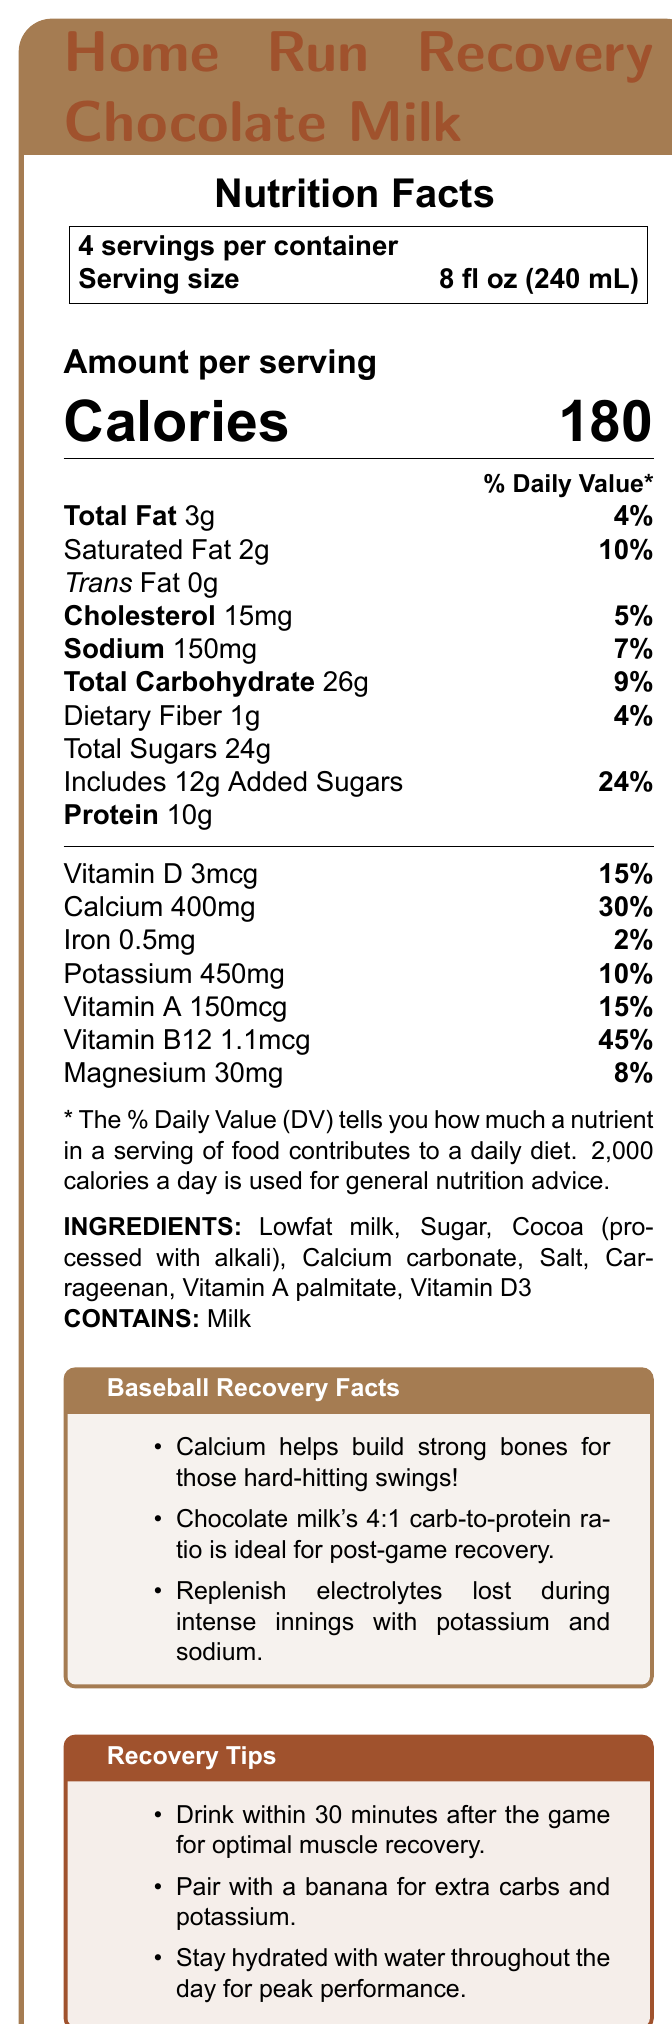What is the serving size of the "Home Run Recovery Chocolate Milk"? The serving size is explicitly mentioned in the document as "8 fl oz (240 mL)".
Answer: 8 fl oz (240 mL) How many calories are there per serving? The document states that each serving contains 180 calories.
Answer: 180 calories How many servings are there per container? The document specifies that there are 4 servings per container.
Answer: 4 What percentage of the daily value of calcium does one serving provide? The document shows that one serving provides 30% of the daily value of calcium.
Answer: 30% What is the amount of protein in one serving? The document lists the amount of protein per serving as 10g.
Answer: 10g What are the total sugars contained in one serving? A. 10g B. 20g C. 24g D. 30g The document states that the total sugars in one serving are 24g.
Answer: C What vitamin has the highest daily value percentage in one serving? A. Vitamin D B. Calcium C. Vitamin B12 D. Magnesium Vitamin B12 has a daily value percentage of 45%, which is the highest compared to the others listed.
Answer: C Does the product contain any trans fat? The document indicates that the product contains 0g of trans fat.
Answer: No Summarize the main points of the nutrition and recovery benefits provided by the "Home Run Recovery Chocolate Milk". The document provides detailed nutritional information and highlights recovery benefits specific to young athletes, making a case for the product as an ideal post-game drink.
Answer: This document provides nutrition facts for the "Home Run Recovery Chocolate Milk," highlighting that one serving (8 fl oz) contains 180 calories, 3g of total fat, and significant amounts of protein (10g) and calcium (30% DV). It is positioned as a post-game recovery drink for young baseball players, emphasizing its ideal 4:1 carb-to-protein ratio for muscle recovery, the importance of calcium for strong bones, and the addition of electrolytes like potassium and sodium. What ingredients does the "Home Run Recovery Chocolate Milk" contain? The document lists all these ingredients under the "INGREDIENTS" section.
Answer: Lowfat milk, Sugar, Cocoa (processed with alkali), Calcium carbonate, Salt, Carrageenan, Vitamin A palmitate, Vitamin D3 What is the sodium content per serving? The document states that the sodium content per serving is 150mg.
Answer: 150mg How many added sugars are there in one serving? The document specifies that there are 12g of added sugars in each serving.
Answer: 12g Name one recovery tip mentioned in the document. This tip is explicitly listed under the "Recovery Tips" section in the document.
Answer: Drink within 30 minutes after the game for optimal muscle recovery. Is the cholesterol content per serving high? The document states that the cholesterol content per serving is 15mg, which is 5% of the daily value, considered low.
Answer: No How much vitamin D is present in one serving? The document states that each serving contains 3mcg of vitamin D.
Answer: 3mcg Does the product contain any allergens? The document mentions in the allergen information section that the product contains milk.
Answer: Yes, Milk How many grams of dietary fiber are in one serving? The document lists the dietary fiber per serving as 1g.
Answer: 1g What is the relationship between carbs and protein in the product according to the baseball recovery facts? The document states that the chocolate milk has a 4:1 carb-to-protein ratio, ideal for post-game recovery.
Answer: 4:1 ratio Which nutrient in the "Home Run Recovery Chocolate Milk" helps replenish electrolytes during intense innings? The document mentions that potassium and sodium help replenish electrolytes lost during intense innings.
Answer: Potassium and Sodium What’s the primary function of calcium mentioned in the Baseball Recovery Facts? The document highlights that calcium helps build strong bones, which is crucial for hard-hitting swings.
Answer: Helps build strong bones for hard-hitting swings Is the product suitable for people with a milk allergy? The document states that the product contains milk, making it unsuitable for people with a milk allergy.
Answer: No What flavor is the "Home Run Recovery Chocolate Milk"? The product name indicates that the flavor is chocolate.
Answer: Chocolate Are there any electrolytes mentioned in the document? If so, which ones? The document lists both sodium and potassium as electrolytes.
Answer: Yes, Sodium and Potassium What percentage of dietary fiber is in a single serving based on daily value? The document specifies that 1g of dietary fiber per serving is 4% of the daily value.
Answer: 4% What can athletes pair with this drink for extra carbs and potassium? One of the recovery tips suggests pairing the drink with a banana for extra carbs and potassium.
Answer: A banana Who can benefit from drinking "Home Run Recovery Chocolate Milk"? The document markets the drink explicitly as a post-game recovery drink for young baseball players.
Answer: Young baseball players What is the main purpose of drinking this product post-game? The document and recovery tips suggest drinking within 30 minutes after the game for optimal muscle recovery.
Answer: To aid in muscle recovery What is the magnesium content per serving? The document specifies that the magnesium content per serving is 30mg.
Answer: 30mg What is the source of the chocolate flavor in this drink? The document lists "Cocoa (processed with alkali)" among the ingredients, which provides the chocolate flavor.
Answer: Cocoa (processed with alkali) How much cholesterol contributes to daily value in percentage per serving? The document mentions that each serving contains 15mg of cholesterol, contributing to 5% of the daily value.
Answer: 5% What percentage of daily value does Vitamin A provide per serving? The document indicates that Vitamin A provides 15% of the daily value per serving.
Answer: 15% What is the total carbohydrate content per serving? The document states that the total carbohydrate per serving is 26g.
Answer: 26g Why is it suggested to stay hydrated with water throughout the day? One of the recovery tips advises staying hydrated with water for peak performance.
Answer: For peak performance What is the daily value percentage of iron in a serving? The document specifies that iron provides 2% of the daily value per serving.
Answer: 2% Which vitamin has the lowest amount per serving according to the document? The document lists Vitamin B12 amount as 1.1mcg, lower in comparison to the other vitamins listed.
Answer: Vitamin B12 What is the main idea of the "Home Run Recovery Chocolate Milk" document? The main purpose of the document is to detail the nutritional benefits and highlight how the chocolate milk aids in recovery for young athletes.
Answer: The document provides the nutritional details and benefits of the "Home Run Recovery Chocolate Milk," emphasizing its suitability as a post-game recovery drink for young baseball players due to its balanced nutrients like calcium, protein, and electrolytes. 